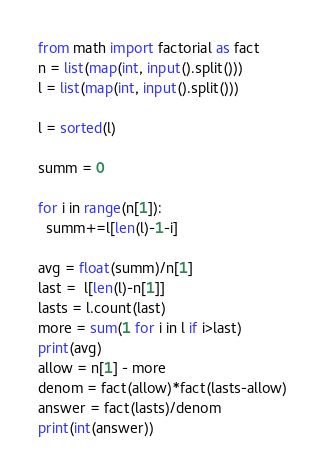<code> <loc_0><loc_0><loc_500><loc_500><_Python_>from math import factorial as fact
n = list(map(int, input().split()))
l = list(map(int, input().split()))

l = sorted(l)

summ = 0

for i in range(n[1]):
  summ+=l[len(l)-1-i]

avg = float(summ)/n[1]
last =  l[len(l)-n[1]]
lasts = l.count(last)
more = sum(1 for i in l if i>last)
print(avg)
allow = n[1] - more
denom = fact(allow)*fact(lasts-allow)
answer = fact(lasts)/denom
print(int(answer))
</code> 